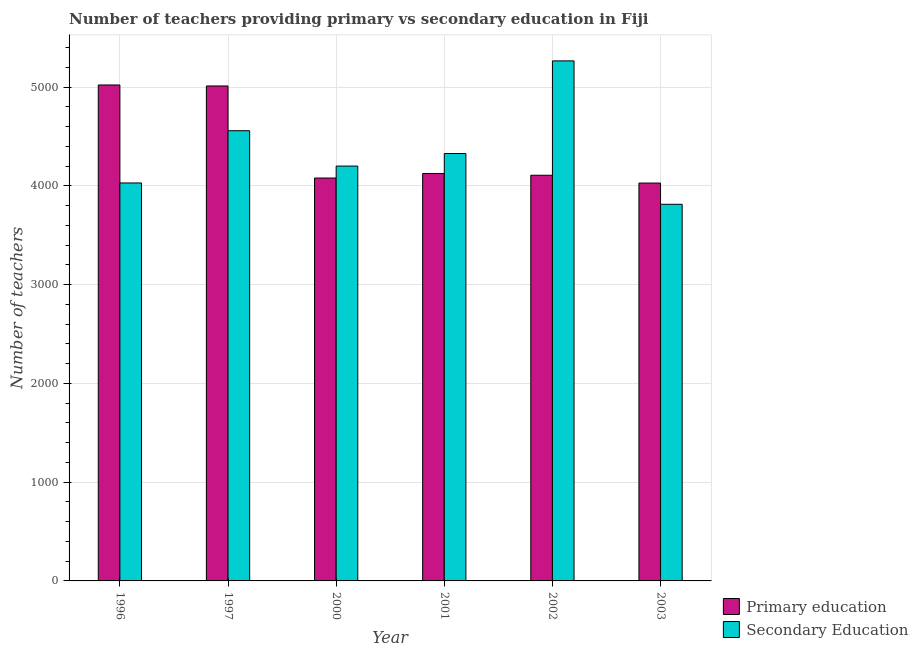How many different coloured bars are there?
Provide a short and direct response. 2. How many groups of bars are there?
Your answer should be compact. 6. Are the number of bars on each tick of the X-axis equal?
Offer a very short reply. Yes. How many bars are there on the 2nd tick from the left?
Your answer should be compact. 2. What is the label of the 3rd group of bars from the left?
Provide a succinct answer. 2000. What is the number of secondary teachers in 2001?
Your answer should be very brief. 4327. Across all years, what is the maximum number of primary teachers?
Keep it short and to the point. 5021. Across all years, what is the minimum number of secondary teachers?
Your response must be concise. 3813. What is the total number of secondary teachers in the graph?
Offer a very short reply. 2.62e+04. What is the difference between the number of secondary teachers in 1997 and that in 2001?
Provide a succinct answer. 231. What is the difference between the number of secondary teachers in 1997 and the number of primary teachers in 2001?
Provide a short and direct response. 231. What is the average number of secondary teachers per year?
Offer a terse response. 4365.33. In the year 1996, what is the difference between the number of secondary teachers and number of primary teachers?
Your answer should be very brief. 0. In how many years, is the number of secondary teachers greater than 2600?
Your answer should be compact. 6. What is the ratio of the number of primary teachers in 1996 to that in 1997?
Keep it short and to the point. 1. What is the difference between the highest and the second highest number of primary teachers?
Keep it short and to the point. 10. What is the difference between the highest and the lowest number of primary teachers?
Your answer should be very brief. 993. In how many years, is the number of primary teachers greater than the average number of primary teachers taken over all years?
Provide a short and direct response. 2. Is the sum of the number of primary teachers in 1997 and 2002 greater than the maximum number of secondary teachers across all years?
Offer a terse response. Yes. What does the 2nd bar from the left in 2001 represents?
Keep it short and to the point. Secondary Education. What does the 1st bar from the right in 1996 represents?
Give a very brief answer. Secondary Education. How many bars are there?
Your response must be concise. 12. Are all the bars in the graph horizontal?
Offer a terse response. No. How many years are there in the graph?
Provide a short and direct response. 6. What is the difference between two consecutive major ticks on the Y-axis?
Your answer should be very brief. 1000. Are the values on the major ticks of Y-axis written in scientific E-notation?
Offer a very short reply. No. Does the graph contain any zero values?
Provide a succinct answer. No. Does the graph contain grids?
Make the answer very short. Yes. How many legend labels are there?
Keep it short and to the point. 2. What is the title of the graph?
Ensure brevity in your answer.  Number of teachers providing primary vs secondary education in Fiji. What is the label or title of the Y-axis?
Your answer should be compact. Number of teachers. What is the Number of teachers in Primary education in 1996?
Make the answer very short. 5021. What is the Number of teachers in Secondary Education in 1996?
Your response must be concise. 4029. What is the Number of teachers of Primary education in 1997?
Your response must be concise. 5011. What is the Number of teachers in Secondary Education in 1997?
Provide a succinct answer. 4558. What is the Number of teachers of Primary education in 2000?
Offer a very short reply. 4079. What is the Number of teachers of Secondary Education in 2000?
Your answer should be compact. 4200. What is the Number of teachers of Primary education in 2001?
Provide a succinct answer. 4125. What is the Number of teachers in Secondary Education in 2001?
Offer a very short reply. 4327. What is the Number of teachers in Primary education in 2002?
Provide a short and direct response. 4107. What is the Number of teachers in Secondary Education in 2002?
Provide a short and direct response. 5265. What is the Number of teachers in Primary education in 2003?
Provide a succinct answer. 4028. What is the Number of teachers in Secondary Education in 2003?
Your response must be concise. 3813. Across all years, what is the maximum Number of teachers in Primary education?
Provide a succinct answer. 5021. Across all years, what is the maximum Number of teachers of Secondary Education?
Provide a short and direct response. 5265. Across all years, what is the minimum Number of teachers in Primary education?
Provide a succinct answer. 4028. Across all years, what is the minimum Number of teachers of Secondary Education?
Offer a very short reply. 3813. What is the total Number of teachers of Primary education in the graph?
Ensure brevity in your answer.  2.64e+04. What is the total Number of teachers of Secondary Education in the graph?
Give a very brief answer. 2.62e+04. What is the difference between the Number of teachers in Primary education in 1996 and that in 1997?
Your answer should be compact. 10. What is the difference between the Number of teachers in Secondary Education in 1996 and that in 1997?
Your response must be concise. -529. What is the difference between the Number of teachers of Primary education in 1996 and that in 2000?
Your answer should be compact. 942. What is the difference between the Number of teachers of Secondary Education in 1996 and that in 2000?
Make the answer very short. -171. What is the difference between the Number of teachers of Primary education in 1996 and that in 2001?
Ensure brevity in your answer.  896. What is the difference between the Number of teachers in Secondary Education in 1996 and that in 2001?
Your answer should be compact. -298. What is the difference between the Number of teachers of Primary education in 1996 and that in 2002?
Your answer should be very brief. 914. What is the difference between the Number of teachers in Secondary Education in 1996 and that in 2002?
Your answer should be very brief. -1236. What is the difference between the Number of teachers in Primary education in 1996 and that in 2003?
Provide a short and direct response. 993. What is the difference between the Number of teachers in Secondary Education in 1996 and that in 2003?
Provide a succinct answer. 216. What is the difference between the Number of teachers in Primary education in 1997 and that in 2000?
Your answer should be very brief. 932. What is the difference between the Number of teachers in Secondary Education in 1997 and that in 2000?
Your answer should be very brief. 358. What is the difference between the Number of teachers in Primary education in 1997 and that in 2001?
Your response must be concise. 886. What is the difference between the Number of teachers of Secondary Education in 1997 and that in 2001?
Keep it short and to the point. 231. What is the difference between the Number of teachers of Primary education in 1997 and that in 2002?
Provide a short and direct response. 904. What is the difference between the Number of teachers of Secondary Education in 1997 and that in 2002?
Provide a succinct answer. -707. What is the difference between the Number of teachers in Primary education in 1997 and that in 2003?
Your answer should be compact. 983. What is the difference between the Number of teachers in Secondary Education in 1997 and that in 2003?
Ensure brevity in your answer.  745. What is the difference between the Number of teachers of Primary education in 2000 and that in 2001?
Ensure brevity in your answer.  -46. What is the difference between the Number of teachers of Secondary Education in 2000 and that in 2001?
Offer a very short reply. -127. What is the difference between the Number of teachers in Secondary Education in 2000 and that in 2002?
Provide a short and direct response. -1065. What is the difference between the Number of teachers of Secondary Education in 2000 and that in 2003?
Offer a terse response. 387. What is the difference between the Number of teachers of Primary education in 2001 and that in 2002?
Your answer should be very brief. 18. What is the difference between the Number of teachers in Secondary Education in 2001 and that in 2002?
Make the answer very short. -938. What is the difference between the Number of teachers in Primary education in 2001 and that in 2003?
Ensure brevity in your answer.  97. What is the difference between the Number of teachers in Secondary Education in 2001 and that in 2003?
Provide a succinct answer. 514. What is the difference between the Number of teachers of Primary education in 2002 and that in 2003?
Your answer should be very brief. 79. What is the difference between the Number of teachers of Secondary Education in 2002 and that in 2003?
Offer a terse response. 1452. What is the difference between the Number of teachers in Primary education in 1996 and the Number of teachers in Secondary Education in 1997?
Make the answer very short. 463. What is the difference between the Number of teachers in Primary education in 1996 and the Number of teachers in Secondary Education in 2000?
Offer a terse response. 821. What is the difference between the Number of teachers of Primary education in 1996 and the Number of teachers of Secondary Education in 2001?
Your response must be concise. 694. What is the difference between the Number of teachers of Primary education in 1996 and the Number of teachers of Secondary Education in 2002?
Your response must be concise. -244. What is the difference between the Number of teachers of Primary education in 1996 and the Number of teachers of Secondary Education in 2003?
Keep it short and to the point. 1208. What is the difference between the Number of teachers of Primary education in 1997 and the Number of teachers of Secondary Education in 2000?
Offer a terse response. 811. What is the difference between the Number of teachers of Primary education in 1997 and the Number of teachers of Secondary Education in 2001?
Make the answer very short. 684. What is the difference between the Number of teachers in Primary education in 1997 and the Number of teachers in Secondary Education in 2002?
Your answer should be compact. -254. What is the difference between the Number of teachers in Primary education in 1997 and the Number of teachers in Secondary Education in 2003?
Provide a succinct answer. 1198. What is the difference between the Number of teachers of Primary education in 2000 and the Number of teachers of Secondary Education in 2001?
Offer a very short reply. -248. What is the difference between the Number of teachers of Primary education in 2000 and the Number of teachers of Secondary Education in 2002?
Your response must be concise. -1186. What is the difference between the Number of teachers in Primary education in 2000 and the Number of teachers in Secondary Education in 2003?
Your answer should be compact. 266. What is the difference between the Number of teachers in Primary education in 2001 and the Number of teachers in Secondary Education in 2002?
Keep it short and to the point. -1140. What is the difference between the Number of teachers of Primary education in 2001 and the Number of teachers of Secondary Education in 2003?
Ensure brevity in your answer.  312. What is the difference between the Number of teachers of Primary education in 2002 and the Number of teachers of Secondary Education in 2003?
Your answer should be very brief. 294. What is the average Number of teachers of Primary education per year?
Make the answer very short. 4395.17. What is the average Number of teachers of Secondary Education per year?
Give a very brief answer. 4365.33. In the year 1996, what is the difference between the Number of teachers of Primary education and Number of teachers of Secondary Education?
Offer a terse response. 992. In the year 1997, what is the difference between the Number of teachers of Primary education and Number of teachers of Secondary Education?
Provide a short and direct response. 453. In the year 2000, what is the difference between the Number of teachers in Primary education and Number of teachers in Secondary Education?
Provide a short and direct response. -121. In the year 2001, what is the difference between the Number of teachers in Primary education and Number of teachers in Secondary Education?
Your answer should be very brief. -202. In the year 2002, what is the difference between the Number of teachers of Primary education and Number of teachers of Secondary Education?
Offer a very short reply. -1158. In the year 2003, what is the difference between the Number of teachers in Primary education and Number of teachers in Secondary Education?
Your response must be concise. 215. What is the ratio of the Number of teachers of Secondary Education in 1996 to that in 1997?
Ensure brevity in your answer.  0.88. What is the ratio of the Number of teachers in Primary education in 1996 to that in 2000?
Ensure brevity in your answer.  1.23. What is the ratio of the Number of teachers of Secondary Education in 1996 to that in 2000?
Offer a terse response. 0.96. What is the ratio of the Number of teachers in Primary education in 1996 to that in 2001?
Ensure brevity in your answer.  1.22. What is the ratio of the Number of teachers in Secondary Education in 1996 to that in 2001?
Provide a short and direct response. 0.93. What is the ratio of the Number of teachers in Primary education in 1996 to that in 2002?
Your response must be concise. 1.22. What is the ratio of the Number of teachers of Secondary Education in 1996 to that in 2002?
Make the answer very short. 0.77. What is the ratio of the Number of teachers of Primary education in 1996 to that in 2003?
Make the answer very short. 1.25. What is the ratio of the Number of teachers in Secondary Education in 1996 to that in 2003?
Make the answer very short. 1.06. What is the ratio of the Number of teachers of Primary education in 1997 to that in 2000?
Offer a very short reply. 1.23. What is the ratio of the Number of teachers of Secondary Education in 1997 to that in 2000?
Your answer should be compact. 1.09. What is the ratio of the Number of teachers of Primary education in 1997 to that in 2001?
Provide a succinct answer. 1.21. What is the ratio of the Number of teachers of Secondary Education in 1997 to that in 2001?
Provide a short and direct response. 1.05. What is the ratio of the Number of teachers of Primary education in 1997 to that in 2002?
Provide a succinct answer. 1.22. What is the ratio of the Number of teachers of Secondary Education in 1997 to that in 2002?
Your answer should be compact. 0.87. What is the ratio of the Number of teachers of Primary education in 1997 to that in 2003?
Keep it short and to the point. 1.24. What is the ratio of the Number of teachers in Secondary Education in 1997 to that in 2003?
Offer a very short reply. 1.2. What is the ratio of the Number of teachers in Primary education in 2000 to that in 2001?
Offer a very short reply. 0.99. What is the ratio of the Number of teachers of Secondary Education in 2000 to that in 2001?
Offer a very short reply. 0.97. What is the ratio of the Number of teachers in Primary education in 2000 to that in 2002?
Your answer should be very brief. 0.99. What is the ratio of the Number of teachers of Secondary Education in 2000 to that in 2002?
Offer a very short reply. 0.8. What is the ratio of the Number of teachers of Primary education in 2000 to that in 2003?
Your response must be concise. 1.01. What is the ratio of the Number of teachers of Secondary Education in 2000 to that in 2003?
Your answer should be compact. 1.1. What is the ratio of the Number of teachers in Secondary Education in 2001 to that in 2002?
Keep it short and to the point. 0.82. What is the ratio of the Number of teachers of Primary education in 2001 to that in 2003?
Provide a succinct answer. 1.02. What is the ratio of the Number of teachers of Secondary Education in 2001 to that in 2003?
Your answer should be compact. 1.13. What is the ratio of the Number of teachers of Primary education in 2002 to that in 2003?
Provide a succinct answer. 1.02. What is the ratio of the Number of teachers in Secondary Education in 2002 to that in 2003?
Give a very brief answer. 1.38. What is the difference between the highest and the second highest Number of teachers in Secondary Education?
Offer a terse response. 707. What is the difference between the highest and the lowest Number of teachers of Primary education?
Your answer should be compact. 993. What is the difference between the highest and the lowest Number of teachers of Secondary Education?
Ensure brevity in your answer.  1452. 